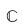<formula> <loc_0><loc_0><loc_500><loc_500>\mathbb { C }</formula> 